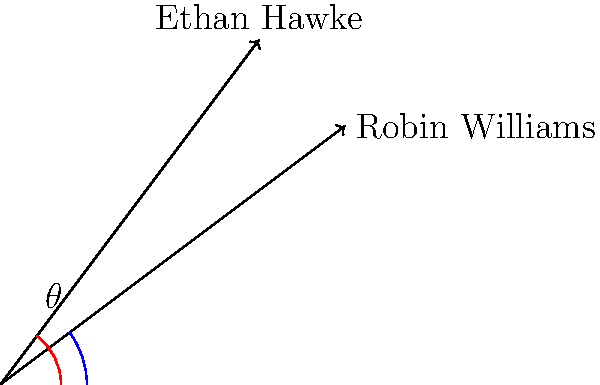In the diagram, vectors representing the genre diversity of Robin Williams and Ethan Hawke's filmographies are shown. If the angle between these vectors is $\theta$, what is $\cos \theta$? To find $\cos \theta$, we can use the dot product formula for two vectors:

1) Let $\vec{a} = (4,3)$ represent Robin Williams' filmography vector
   Let $\vec{b} = (3,4)$ represent Ethan Hawke's filmography vector

2) The dot product formula states: $\vec{a} \cdot \vec{b} = |\vec{a}||\vec{b}|\cos \theta$

3) Calculate the dot product:
   $\vec{a} \cdot \vec{b} = (4)(3) + (3)(4) = 12 + 12 = 24$

4) Calculate the magnitudes:
   $|\vec{a}| = \sqrt{4^2 + 3^2} = \sqrt{25} = 5$
   $|\vec{b}| = \sqrt{3^2 + 4^2} = \sqrt{25} = 5$

5) Substitute into the formula:
   $24 = (5)(5)\cos \theta$

6) Solve for $\cos \theta$:
   $\cos \theta = \frac{24}{25} = 0.96$

Therefore, $\cos \theta = 0.96$.
Answer: 0.96 